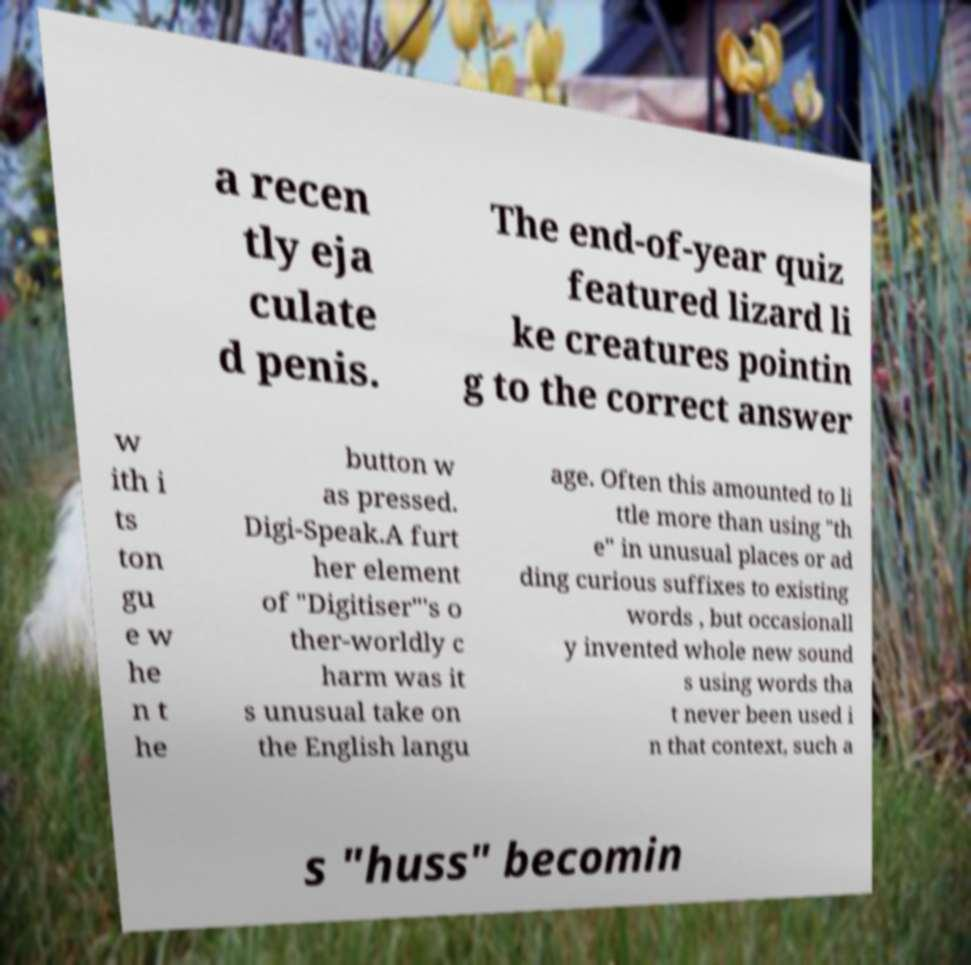Could you extract and type out the text from this image? a recen tly eja culate d penis. The end-of-year quiz featured lizard li ke creatures pointin g to the correct answer w ith i ts ton gu e w he n t he button w as pressed. Digi-Speak.A furt her element of "Digitiser"'s o ther-worldly c harm was it s unusual take on the English langu age. Often this amounted to li ttle more than using "th e" in unusual places or ad ding curious suffixes to existing words , but occasionall y invented whole new sound s using words tha t never been used i n that context, such a s "huss" becomin 